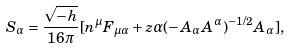<formula> <loc_0><loc_0><loc_500><loc_500>S _ { \alpha } = \frac { \sqrt { - h } } { 1 6 \pi } [ n ^ { \mu } F _ { \mu \alpha } + z \alpha ( - A _ { \alpha } A ^ { \alpha } ) ^ { - 1 / 2 } A _ { \alpha } ] ,</formula> 